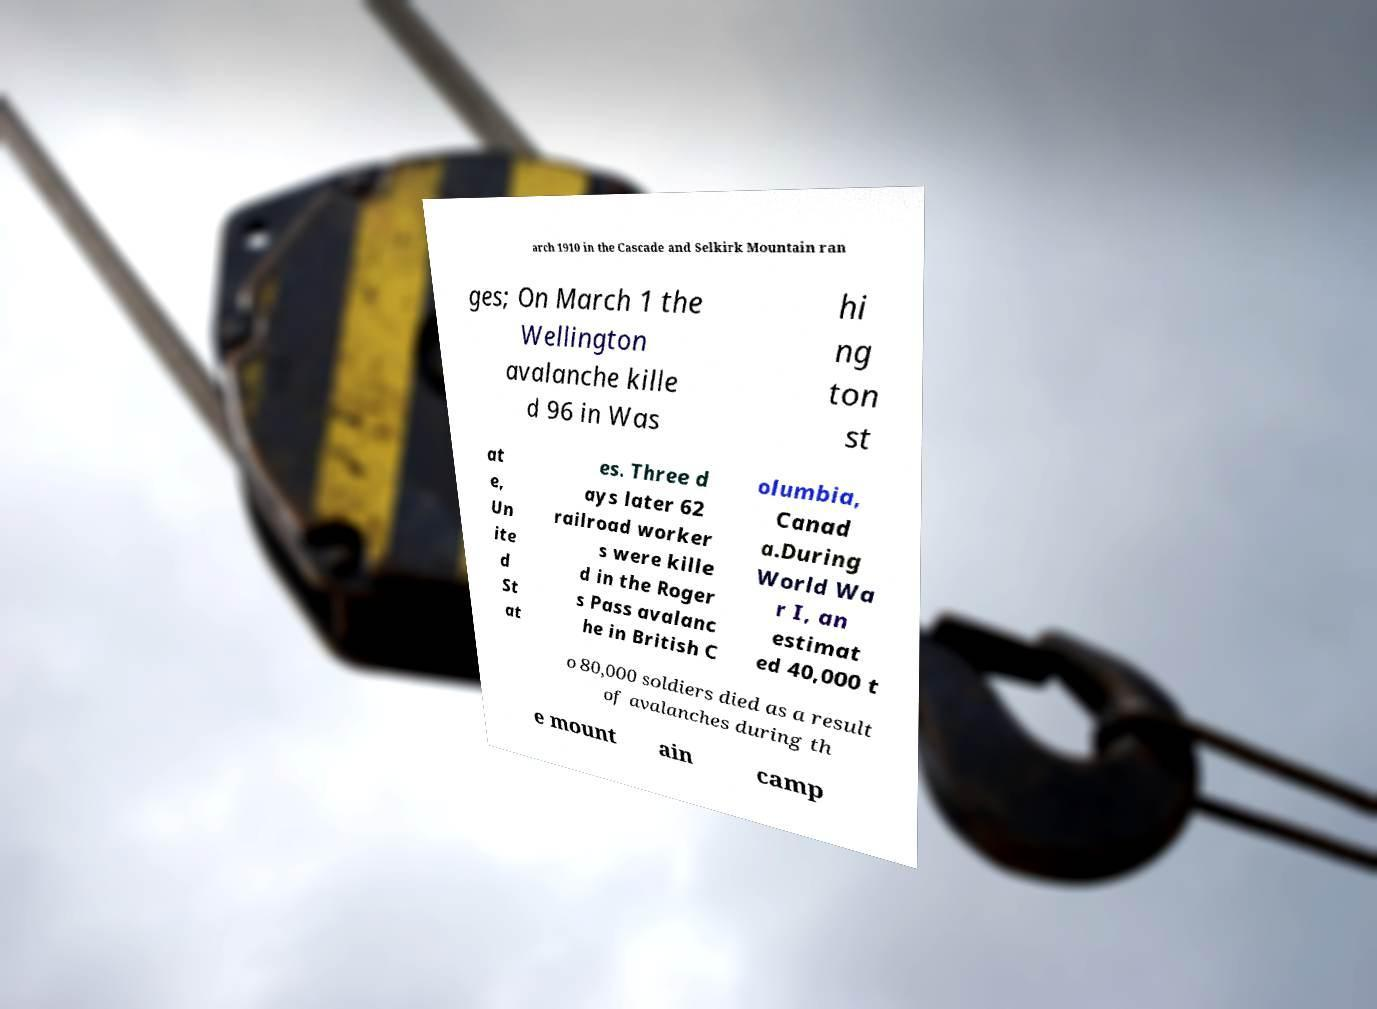Can you read and provide the text displayed in the image?This photo seems to have some interesting text. Can you extract and type it out for me? arch 1910 in the Cascade and Selkirk Mountain ran ges; On March 1 the Wellington avalanche kille d 96 in Was hi ng ton st at e, Un ite d St at es. Three d ays later 62 railroad worker s were kille d in the Roger s Pass avalanc he in British C olumbia, Canad a.During World Wa r I, an estimat ed 40,000 t o 80,000 soldiers died as a result of avalanches during th e mount ain camp 